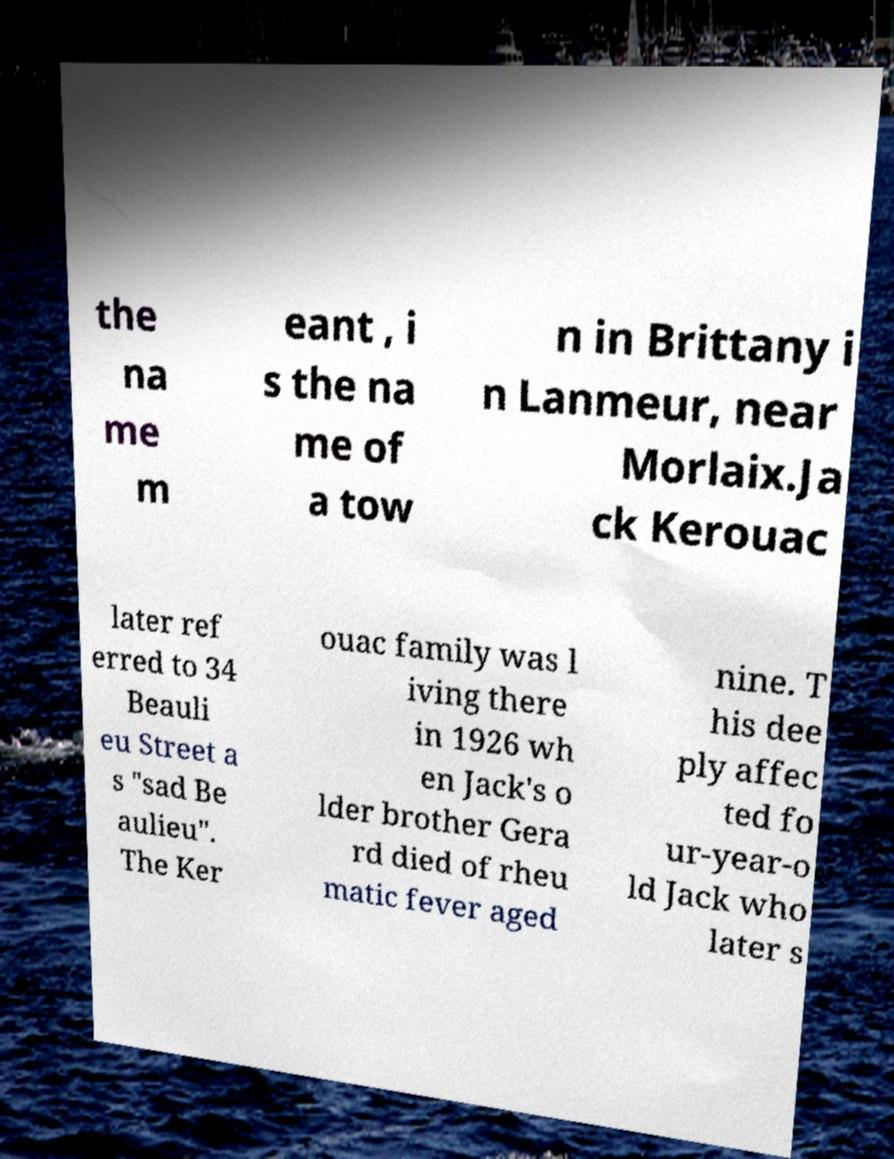Can you read and provide the text displayed in the image?This photo seems to have some interesting text. Can you extract and type it out for me? the na me m eant , i s the na me of a tow n in Brittany i n Lanmeur, near Morlaix.Ja ck Kerouac later ref erred to 34 Beauli eu Street a s "sad Be aulieu". The Ker ouac family was l iving there in 1926 wh en Jack's o lder brother Gera rd died of rheu matic fever aged nine. T his dee ply affec ted fo ur-year-o ld Jack who later s 